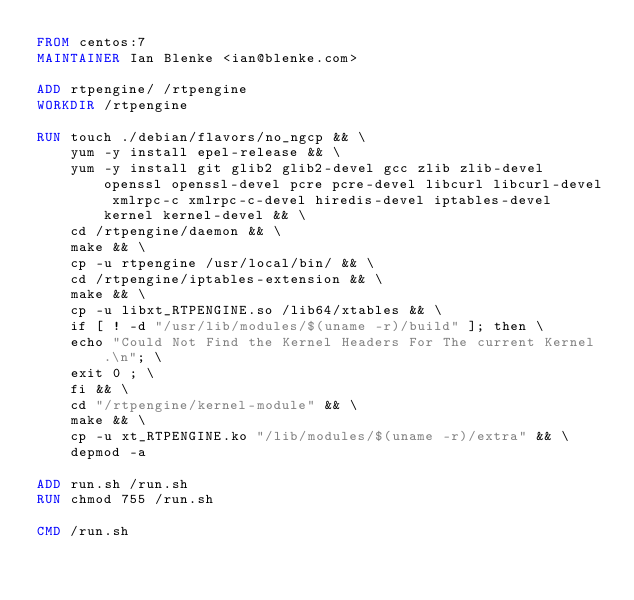<code> <loc_0><loc_0><loc_500><loc_500><_Dockerfile_>FROM centos:7
MAINTAINER Ian Blenke <ian@blenke.com>

ADD rtpengine/ /rtpengine
WORKDIR /rtpengine

RUN touch ./debian/flavors/no_ngcp && \
    yum -y install epel-release && \
    yum -y install git glib2 glib2-devel gcc zlib zlib-devel openssl openssl-devel pcre pcre-devel libcurl libcurl-devel xmlrpc-c xmlrpc-c-devel hiredis-devel iptables-devel kernel kernel-devel && \
    cd /rtpengine/daemon && \
    make && \
    cp -u rtpengine /usr/local/bin/ && \
    cd /rtpengine/iptables-extension && \
    make && \
    cp -u libxt_RTPENGINE.so /lib64/xtables && \
    if [ ! -d "/usr/lib/modules/$(uname -r)/build" ]; then \
	echo "Could Not Find the Kernel Headers For The current Kernel.\n"; \
	exit 0 ; \
    fi && \
    cd "/rtpengine/kernel-module" && \
    make && \
    cp -u xt_RTPENGINE.ko "/lib/modules/$(uname -r)/extra" && \
    depmod -a

ADD run.sh /run.sh
RUN chmod 755 /run.sh

CMD /run.sh
</code> 